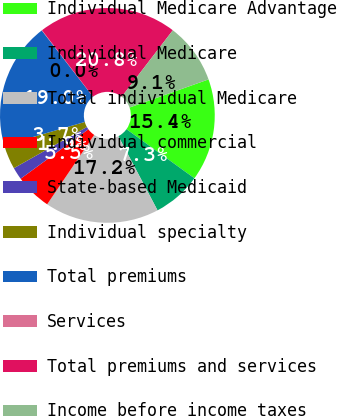Convert chart to OTSL. <chart><loc_0><loc_0><loc_500><loc_500><pie_chart><fcel>Individual Medicare Advantage<fcel>Individual Medicare<fcel>Total individual Medicare<fcel>Individual commercial<fcel>State-based Medicaid<fcel>Individual specialty<fcel>Total premiums<fcel>Services<fcel>Total premiums and services<fcel>Income before income taxes<nl><fcel>15.4%<fcel>7.31%<fcel>17.21%<fcel>5.49%<fcel>1.86%<fcel>3.68%<fcel>19.03%<fcel>0.05%<fcel>20.85%<fcel>9.13%<nl></chart> 